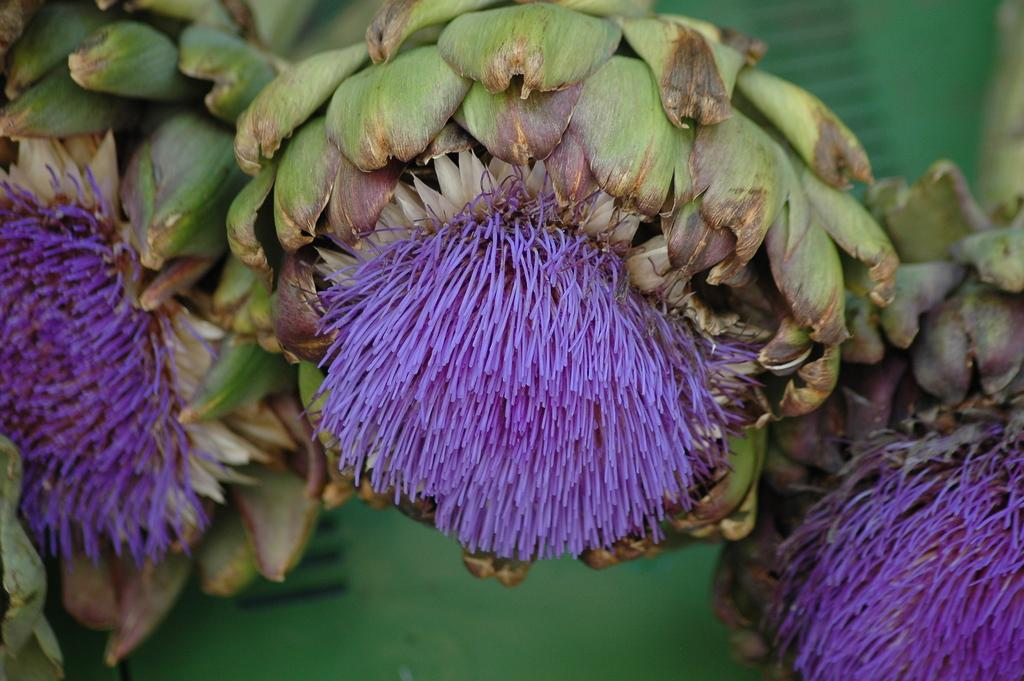What type of vegetable is present in the image? There are artichokes in the image. What type of mine can be seen in the image? There is no mine present in the image; it features artichokes. What type of amusement can be seen in the image? There is no amusement present in the image; it features artichokes. 